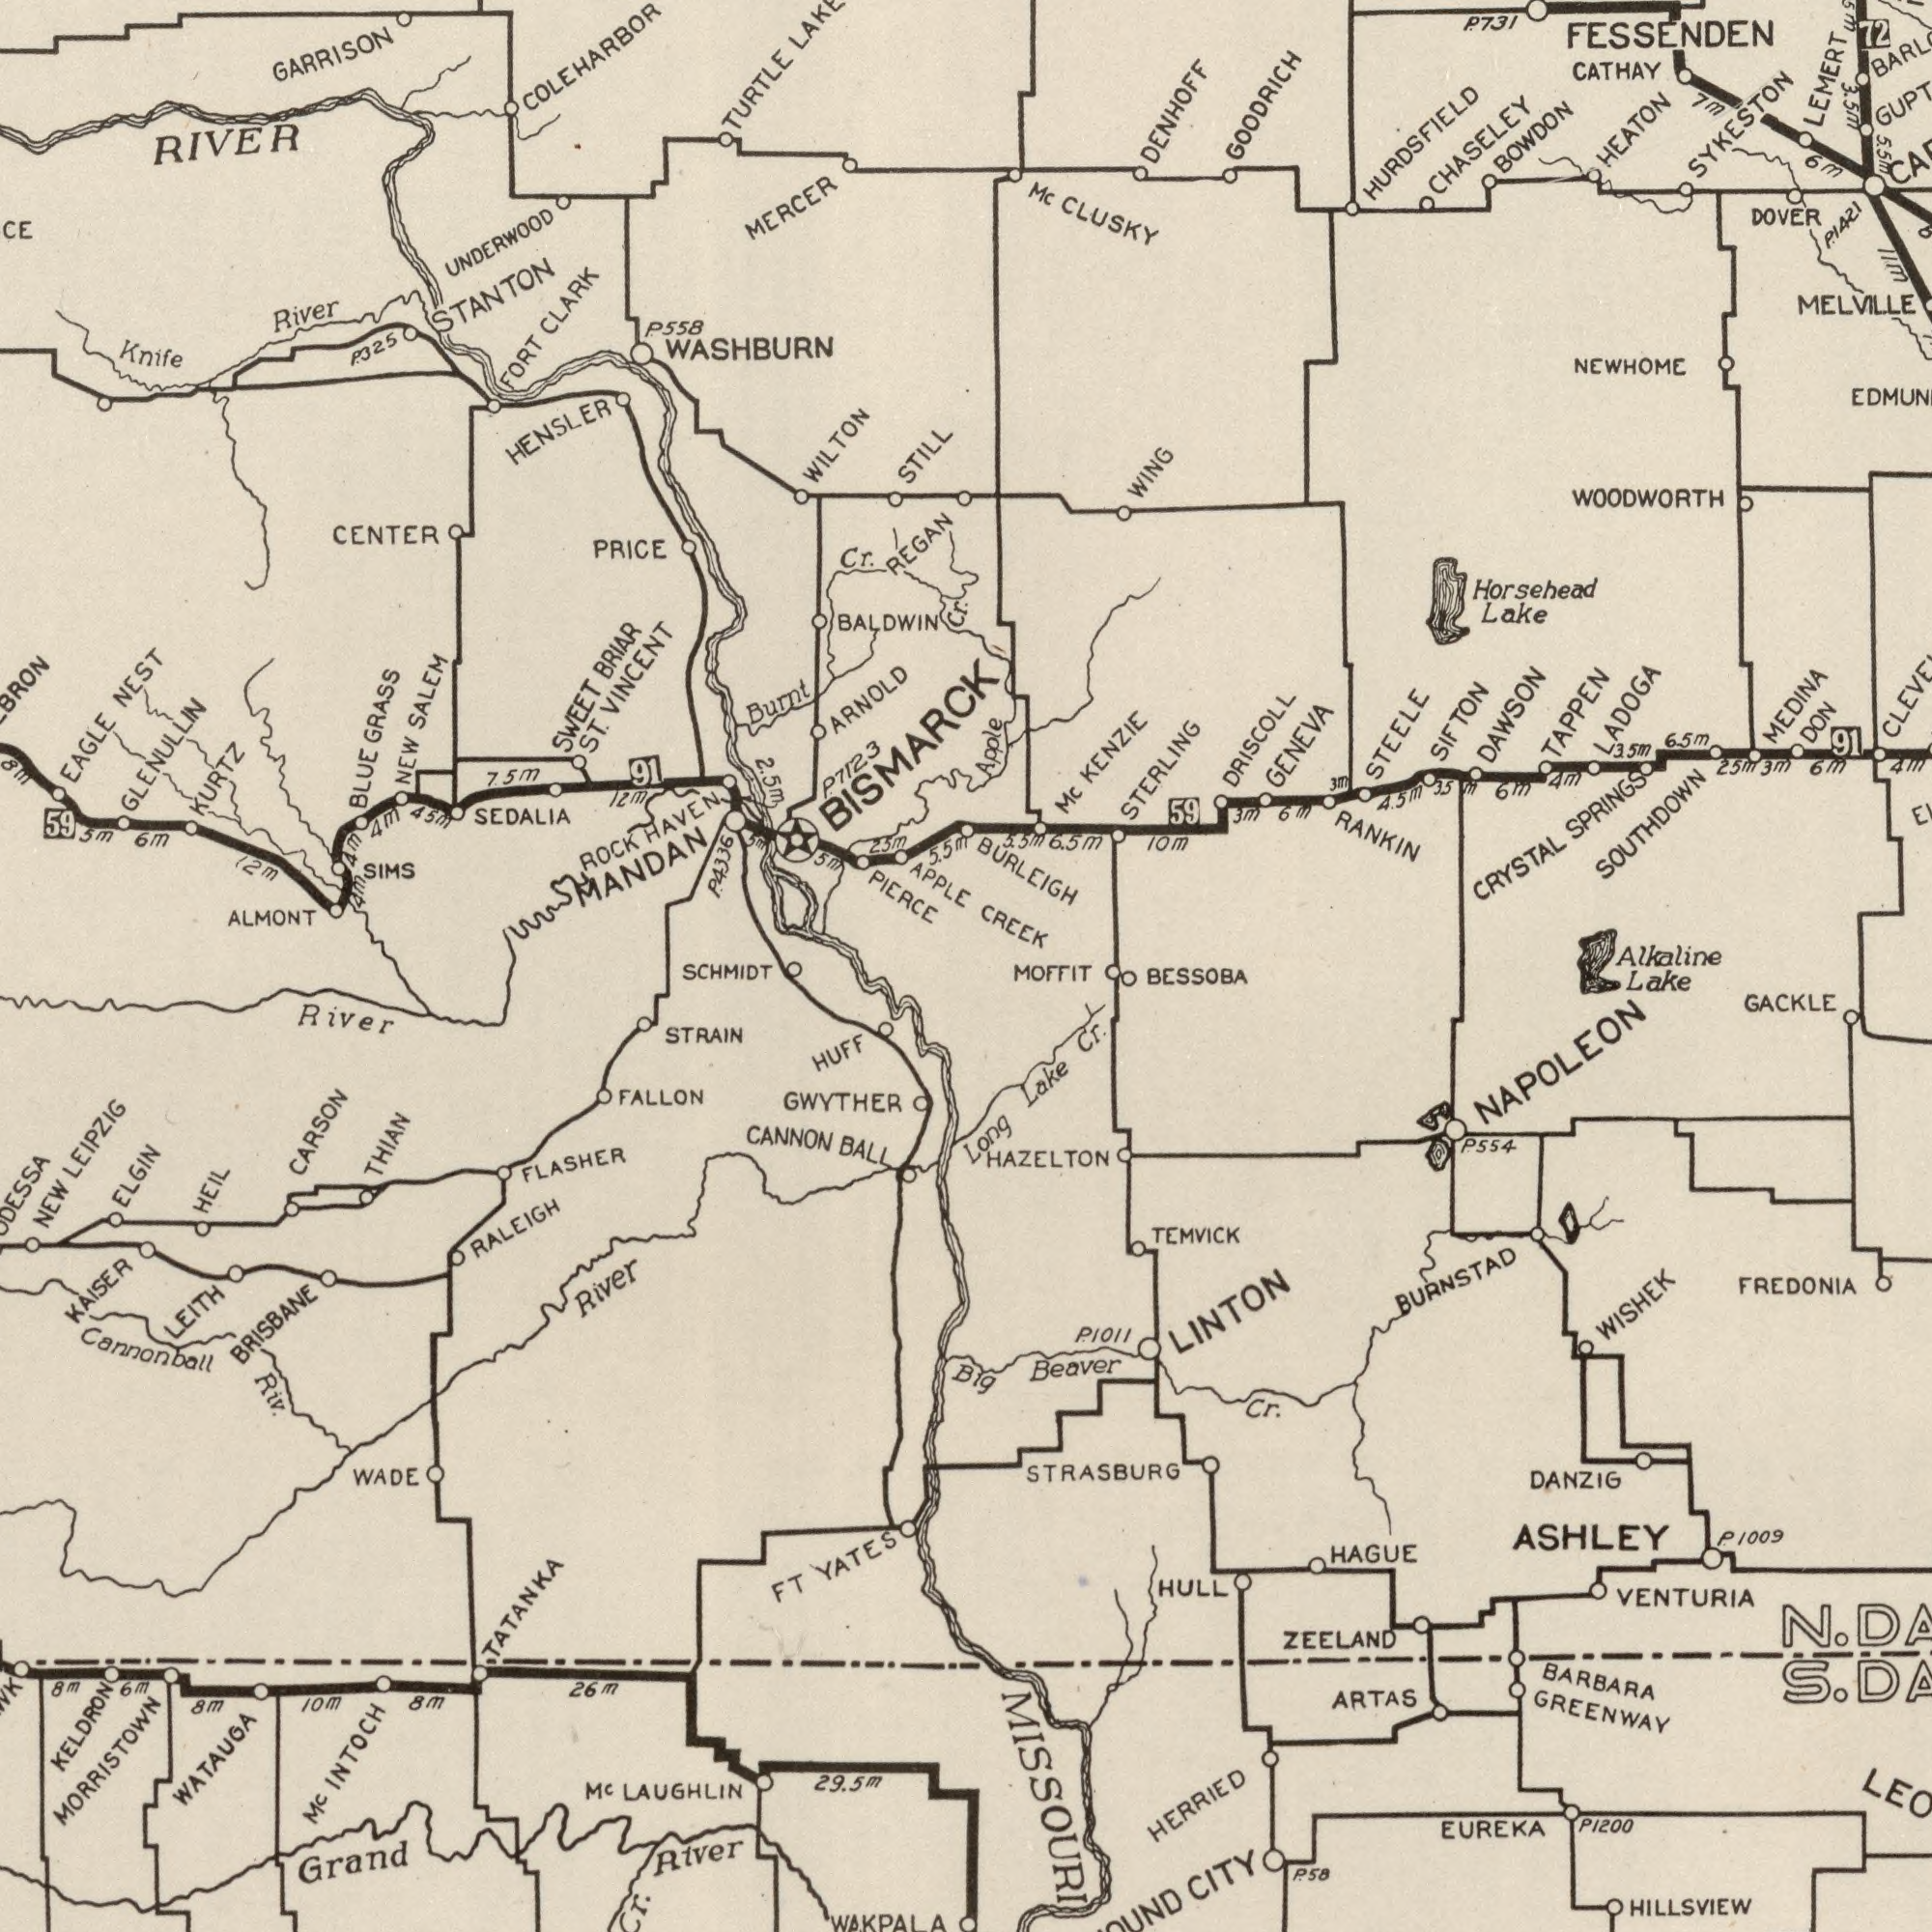What text is shown in the top-right quadrant? HURDSFIELD FESSENDEN SYKESTON SOUTHDOWN WOODWORTH NEWHOME STERLING MELVILLE GENEVA BURLEIGH BOWDON Mc DAWSON KENZIE STEELE CHASELEY RANKIN HEATON CRYSTAL DOVER Apple CLUSKY CATHAY 731 SPRINGS GOODRICH WING TAPPEN Lake CREEK DENHOFF LADOGA 6.5m 6m DRISCOLL 10m 4.5m 6m DON LEMERT Mc MEDINA 1421 59 3m 6m 3.5m SIFTON Alkaline 3m 25m 6m 91 4m 35m 4m 72 Horsehead 7M 5.5m 5.5m 11m 6.5m 3m P. P. 3.5m What text appears in the top-left area of the image? WASHBURN MERCER GARRISON GRASS RIVER ALMONT ARNOLD SEDALIA PIERCE PRICE EAGLE APPLE River Burnt BRIAR BALDWIN TURTLE KURTZ CLARK REGAN STANTON VINCENT UNDERWOOD HENSLER CENTER 325 SWEET 6m 7.5m NEW 558 STILL COLEHARBOR Knife 25m ST. GLENULLIN ROCK 12m SALEM HAVEN FORT 45m 5.5m 7123 NEST 5m WILTON 4m SIMS 2.5m 12m BLUE BISMARCK 4m 59 8m Cr. Cr. 91 4m 5m MANDAN 5m P. P. P. P. 4336 What text appears in the bottom-left area of the image? Grand Cannonball GWYTHER LAUGHLIN WATAUGA CANNON KAISER River CARSON NEW River STRAIN KELDRON RALEIGH WADE BRISBANE BALL 8m HEIL Riv. 26m TATANKA ELGIN HUFF YATES FT 8m FALLON LEITH Mc 10m 8m FLASHER River LEIPZIG WAKPALA 6m 29.5m MORRISTOWN INTOCH SCHMIDT Mc THIAN What text is shown in the bottom-right quadrant? STRASBURG BURNSTAD NAPOLEON HERRIED HAZELTON ASHLEY HAGUE Beaver ARTAS DANZIG EUREKA Lake LINTON ZEELAND P1200 GACKLE BARBARA HULL BESSOBA TEMVICK Lake 58 CITY 1009 Long HILLSVIEW MOFFIT 554 1011 WISHEK Cr. Cr. VENTURIA FREDONIA MISSOURI GREENWAY Big P. P. P. N. S. P. 